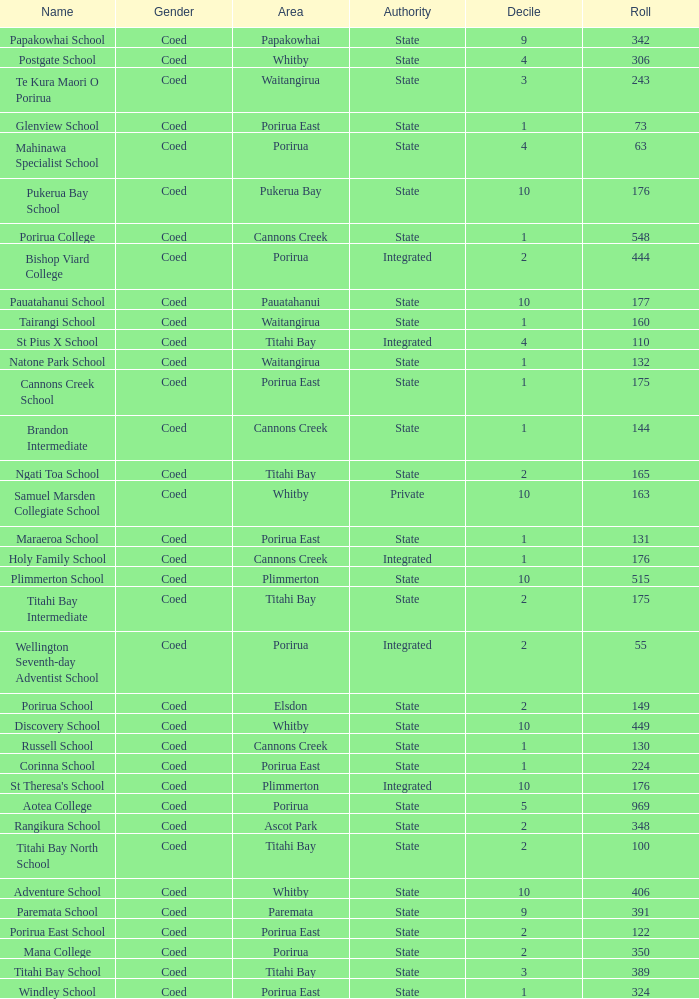What integrated school had a decile of 2 and a roll larger than 55? Bishop Viard College. 